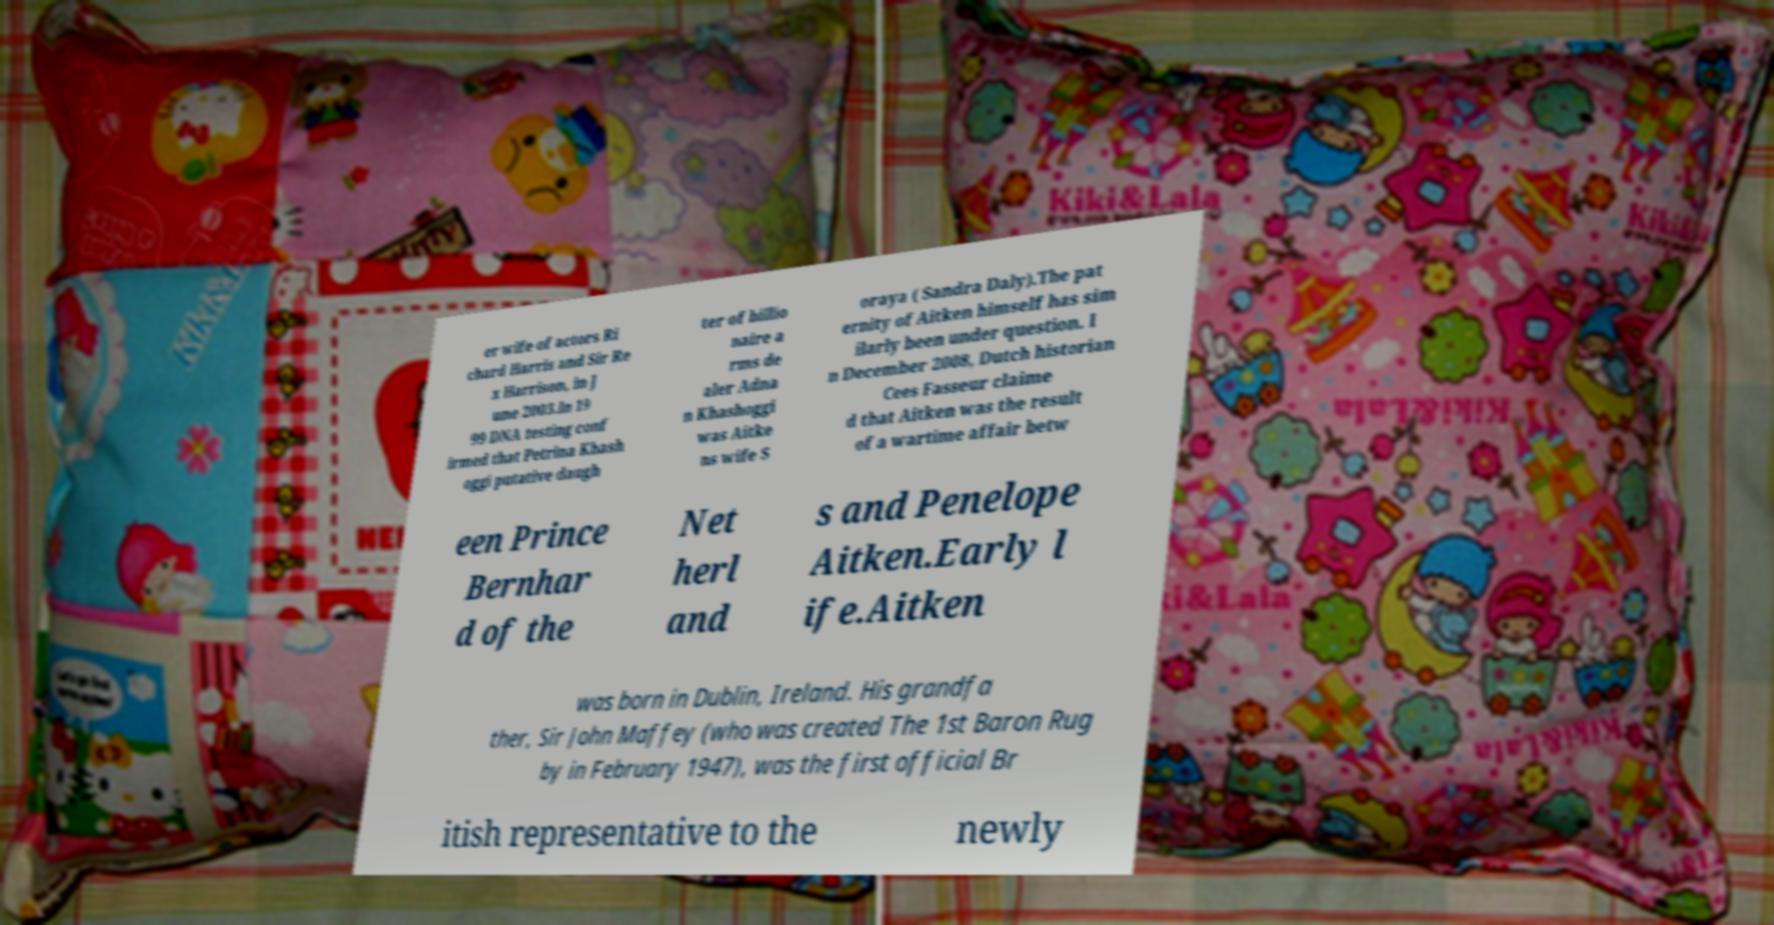Can you accurately transcribe the text from the provided image for me? er wife of actors Ri chard Harris and Sir Re x Harrison, in J une 2003.In 19 99 DNA testing conf irmed that Petrina Khash oggi putative daugh ter of billio naire a rms de aler Adna n Khashoggi was Aitke ns wife S oraya ( Sandra Daly).The pat ernity of Aitken himself has sim ilarly been under question. I n December 2008, Dutch historian Cees Fasseur claime d that Aitken was the result of a wartime affair betw een Prince Bernhar d of the Net herl and s and Penelope Aitken.Early l ife.Aitken was born in Dublin, Ireland. His grandfa ther, Sir John Maffey (who was created The 1st Baron Rug by in February 1947), was the first official Br itish representative to the newly 